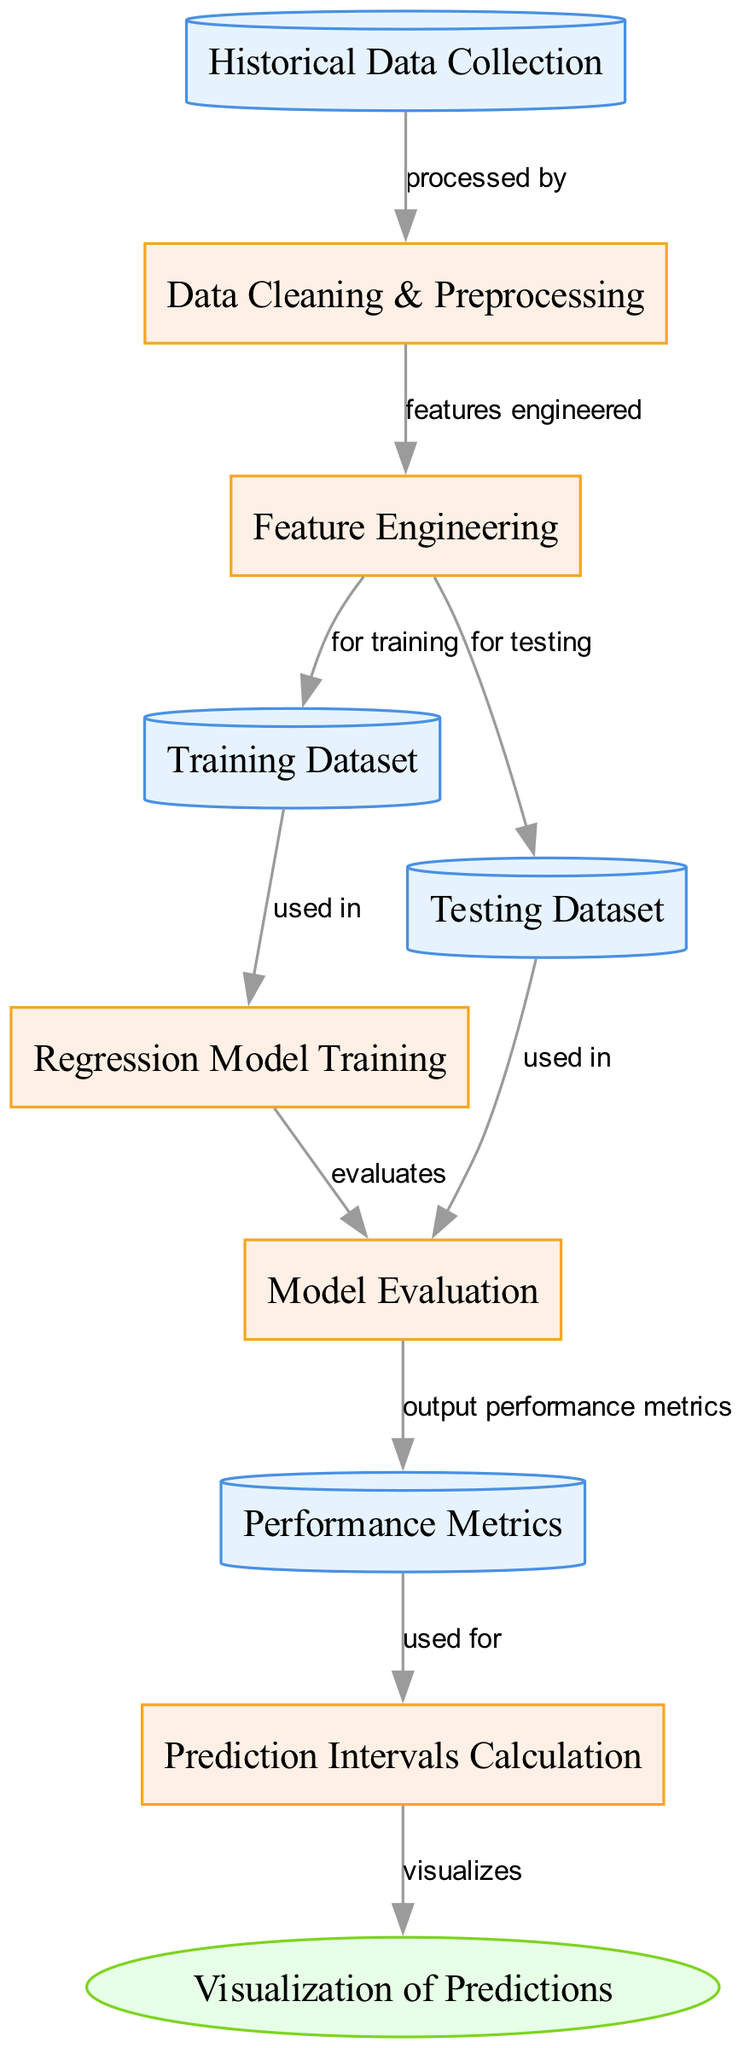What is the first step in the diagram? The first step represented in the diagram is "Historical Data Collection," which is the initial node where data is gathered before processing.
Answer: Historical Data Collection How many nodes are present in the diagram? The diagram contains a total of ten nodes, each representing different stages or components of the predictive analysis process.
Answer: Ten What type of process is represented by "Data Cleaning & Preprocessing"? "Data Cleaning & Preprocessing" is categorized as a process type, indicating that it involves operations to prepare data for further analysis.
Answer: Process Which node leads to "Model Evaluation"? The node "Regression Model Training" leads to "Model Evaluation," indicating that the model's performance is judged after it has been trained.
Answer: Regression Model Training What output does "Model Evaluation" provide? "Model Evaluation" outputs "Performance Metrics," which are measurements used to assess the effectiveness of the regression model after evaluation.
Answer: Performance Metrics Which step comes before "Prediction Intervals Calculation"? The step that comes before "Prediction Intervals Calculation" is "Performance Metrics," which is used to determine the intervals for predictions.
Answer: Performance Metrics What visualization technique is used in the last stage? The last stage utilizes "Visualization of Predictions" as the method to graphically represent the predicted outcomes and intervals after calculations.
Answer: Visualization of Predictions How does "Feature Engineering" relate to the training and testing datasets? "Feature Engineering" processes the data and contributes to both the "Training Dataset" and "Testing Dataset," ensuring that useful features are extracted for both sets.
Answer: For training and testing What is the primary purpose of "Regression Model Training"? The primary purpose of "Regression Model Training" is to create a statistical model that can understand the relationships within the training data and predict future performance effectively.
Answer: To create a statistical model Which process leads directly to "Visualization of Predictions"? "Prediction Intervals Calculation" leads directly to "Visualization of Predictions," indicating that after intervals are calculated, predictions can be visualized.
Answer: Prediction Intervals Calculation 